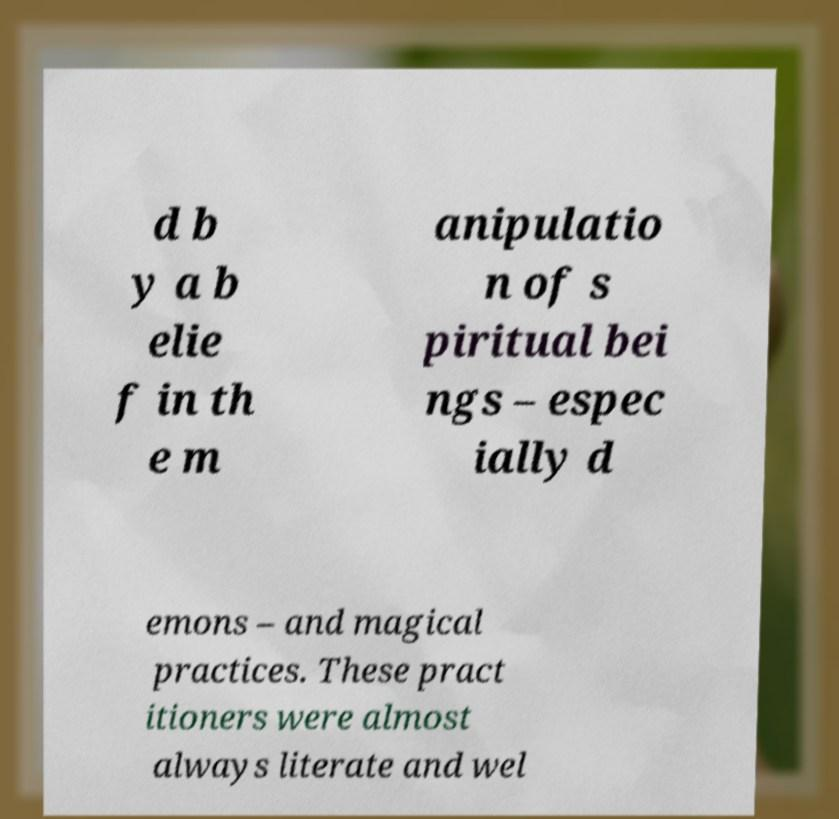Can you accurately transcribe the text from the provided image for me? d b y a b elie f in th e m anipulatio n of s piritual bei ngs – espec ially d emons – and magical practices. These pract itioners were almost always literate and wel 